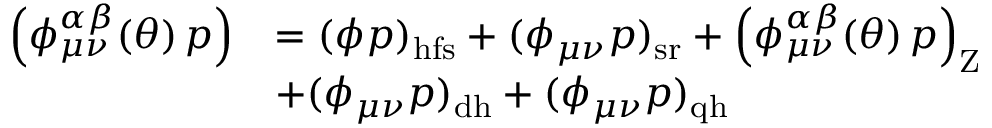<formula> <loc_0><loc_0><loc_500><loc_500>\begin{array} { r l } { \left ( \phi _ { \mu \nu } ^ { \alpha \beta } ( \theta ) \, p \right ) } & { = ( \phi p ) _ { h f s } + ( \phi _ { \mu \nu } p ) _ { s r } + \left ( \phi _ { \mu \nu } ^ { \alpha \beta } ( \theta ) \, p \right ) _ { Z } } \\ & { + ( \phi _ { \mu \nu } p ) _ { d h } + ( \phi _ { \mu \nu } p ) _ { q h } } \end{array}</formula> 